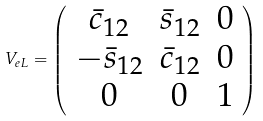<formula> <loc_0><loc_0><loc_500><loc_500>V _ { e L } = \left ( \begin{array} { c c c } { { \bar { c } _ { 1 2 } } } & { { \bar { s } _ { 1 2 } } } & { 0 } \\ { { - \bar { s } _ { 1 2 } } } & { { \bar { c } _ { 1 2 } } } & { 0 } \\ { 0 } & { 0 } & { 1 } \end{array} \right )</formula> 